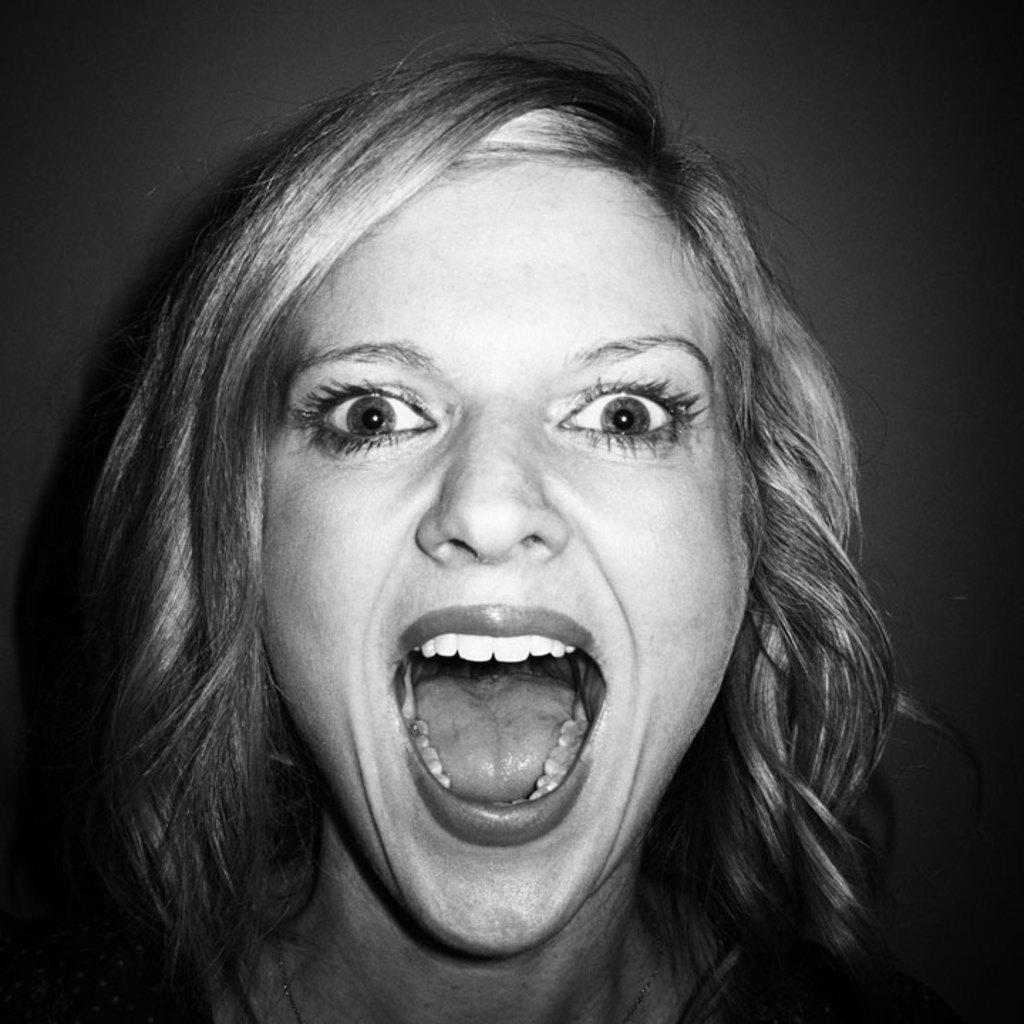Can you describe this image briefly? The picture consists of a woman, she is shouting. The background is blurred. 